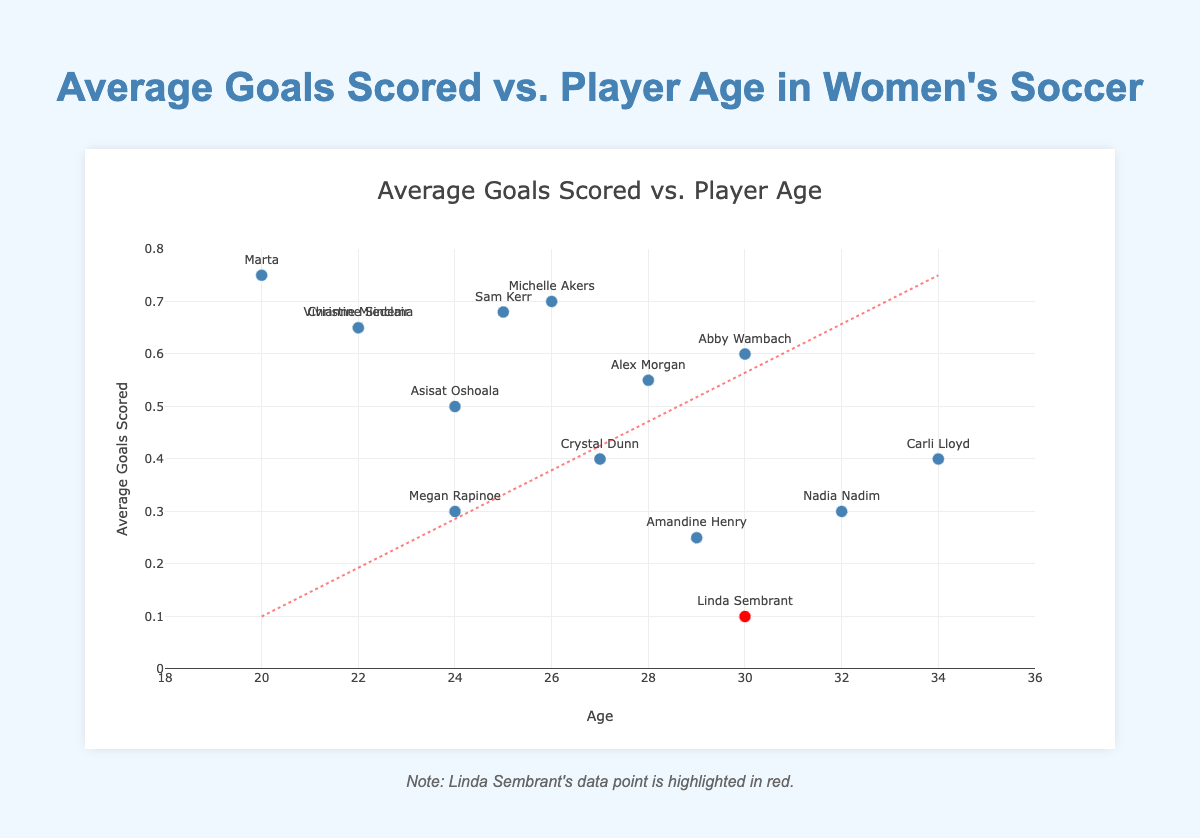What is the title of the figure? The title is displayed at the top of the chart and provides a clear description of the figure's primary focus. The title reads 'Average Goals Scored vs. Player Age in Women's Soccer'.
Answer: 'Average Goals Scored vs. Player Age in Women's Soccer' How many players are there in the data set? The plot visually displays dots representing each player's data. Counting each dot on the scatter plot, which is equivalent to the number of players, yields 14 players.
Answer: 14 Which player has the highest average goals scored and what is it? By looking at the highest point on the y-axis (average goals scored), Marta is seen to have the highest average goals scored of 0.75.
Answer: Marta, 0.75 What is the age of the player with the lowest average goals scored, and who is it? The lowest point on the y-axis represents the player with the fewest average goals. Linda Sembrant, whose dot is highlighted in red, is the player with the lowest average goals scored, at age 30.
Answer: Linda Sembrant, age 30 What is the general trend shown by the trend line in the scatter plot? The trend line is plotted through the data points and appears to have a negative slope, indicating that as age increases, the average goals scored generally decrease.
Answer: As age increases, average goals scored decrease Compare the average goals scored by Christine Sinclair and Nadia Nadim. Who scored higher? By identifying the data points associated with Christine Sinclair and Nadia Nadim, it is clear that Christine Sinclair (0.65) has a higher average goals scored than Nadia Nadim (0.30).
Answer: Christine Sinclair scored higher Calculate the average goals scored by players aged 24. By identifying the players aged 24 (Megan Rapinoe and Asisat Oshoala) and averaging their goals (0.30 + 0.50) / 2, we get (0.80 / 2) = 0.40.
Answer: 0.40 Compare the average goals scored of players aged 22. Who are they and what are their averages? Identifying the players aged 22 (Christine Sinclair and Vivianne Miedema), both have the same average goals scored of 0.65.
Answer: Christine Sinclair and Vivianne Miedema, both 0.65 What is the average age of players who have an average goal score of 0.60 or higher? The players with average goal scores of 0.60 or higher are Marta (20, 0.75), Christine Sinclair (22, 0.65), Vivianne Miedema (22, 0.65), Sam Kerr (25, 0.68), Michelle Akers (26, 0.70), Abby Wambach (30, 0.60). Summing their ages: 20 + 22 + 22 + 25 + 26 + 30 = 145. Dividing by the number of players: 145 / 6 = 24.17 years.
Answer: 24.17 years What is the general relationship illustrated by the trend line between age and performance in scoring goals? The trend line indicates that generally, as the age of the players increases, their performance in average goals scored appears to decrease, demonstrating a negative correlation.
Answer: Negative correlation 